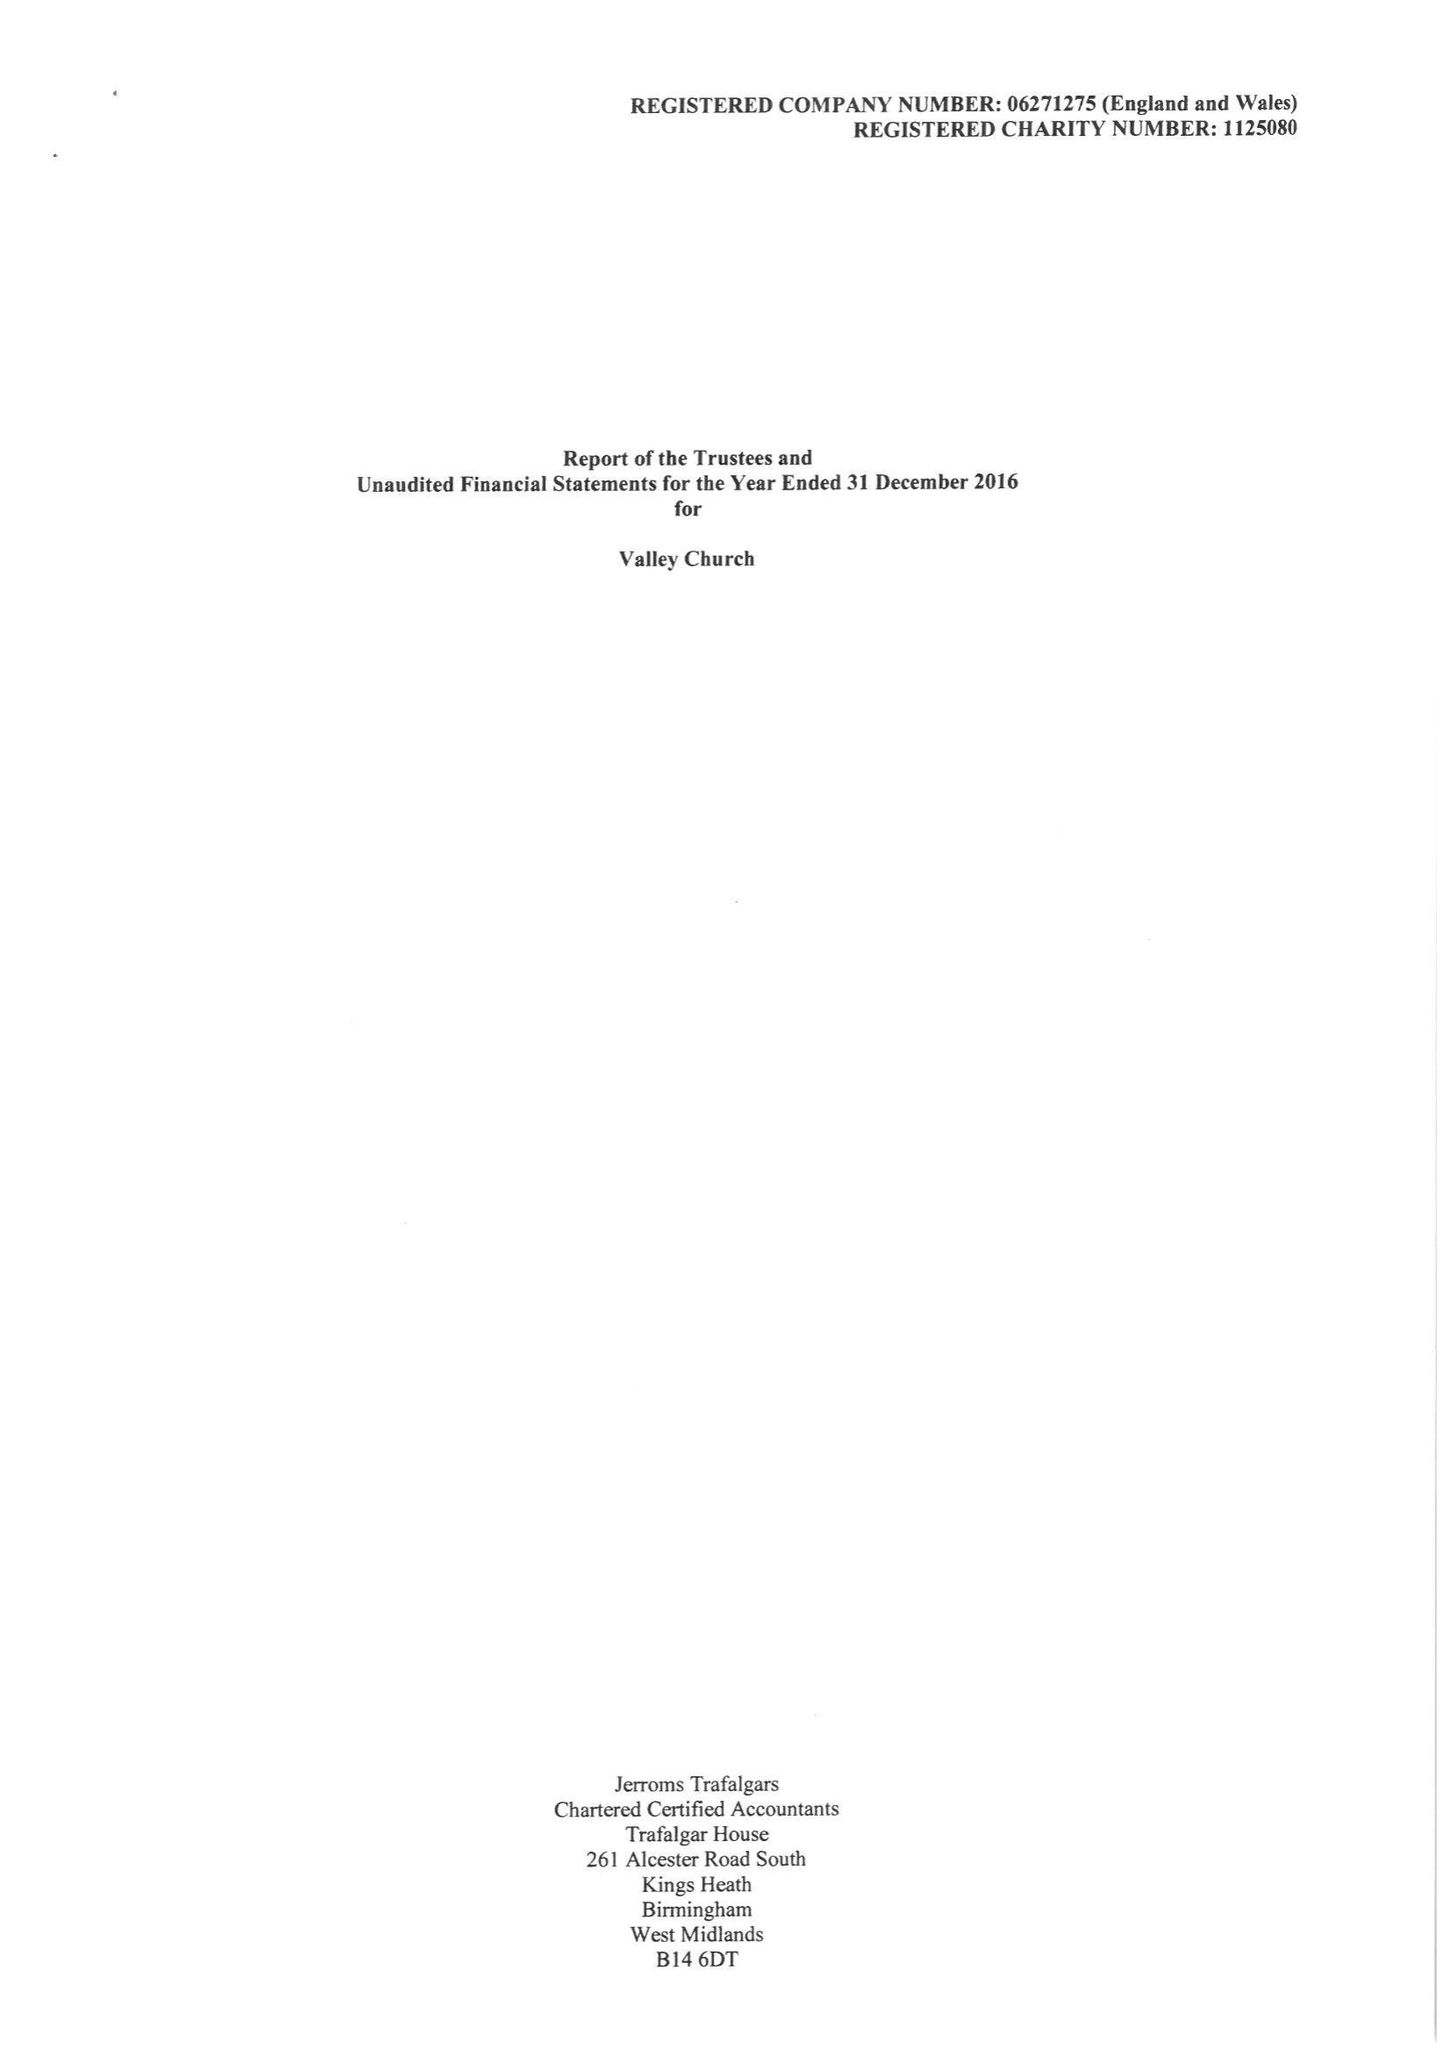What is the value for the report_date?
Answer the question using a single word or phrase. 2016-12-31 